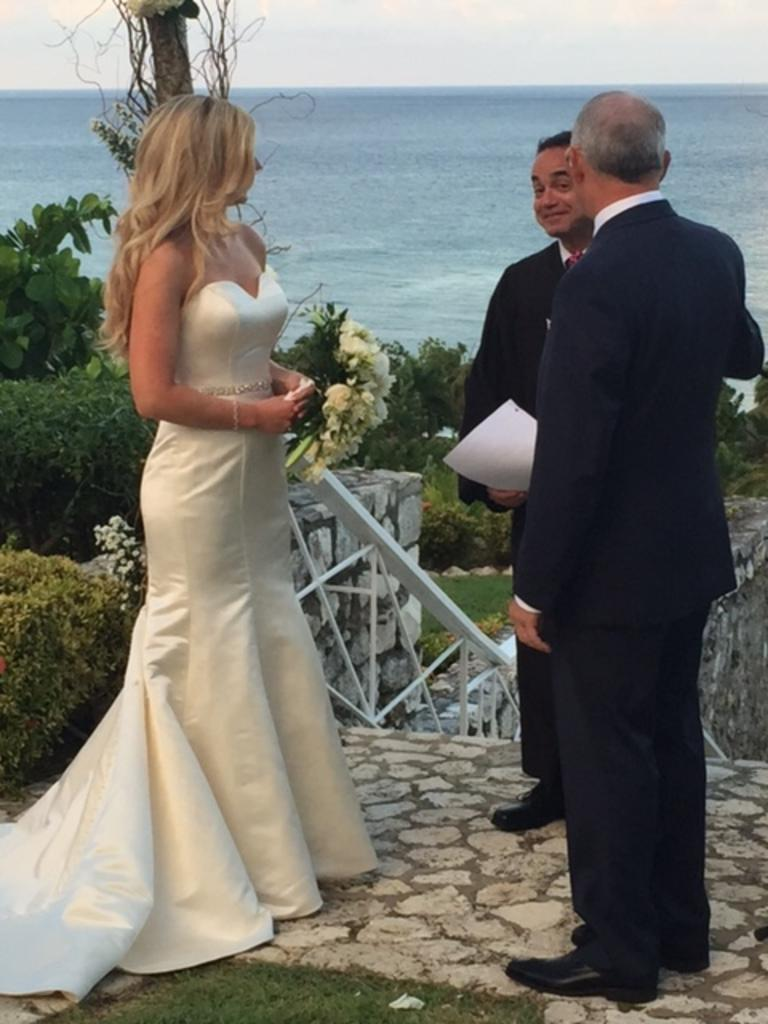How many people are in the image? There are three people in the image. What is the position of the people in the image? The people are standing on the ground. What type of natural environment can be seen in the image? There are trees and water visible in the image. How much jelly is being used by the people in the image? There is no jelly present in the image, so it cannot be determined how much jelly is being used. 